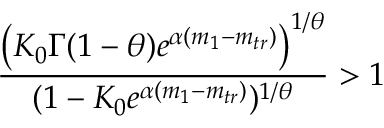<formula> <loc_0><loc_0><loc_500><loc_500>\frac { \left ( K _ { 0 } \Gamma ( 1 - \theta ) e ^ { \alpha ( m _ { 1 } - m _ { t r } ) } \right ) ^ { 1 / \theta } } { ( 1 - K _ { 0 } e ^ { \alpha ( m _ { 1 } - m _ { t r } ) } ) ^ { 1 / \theta } } > 1</formula> 